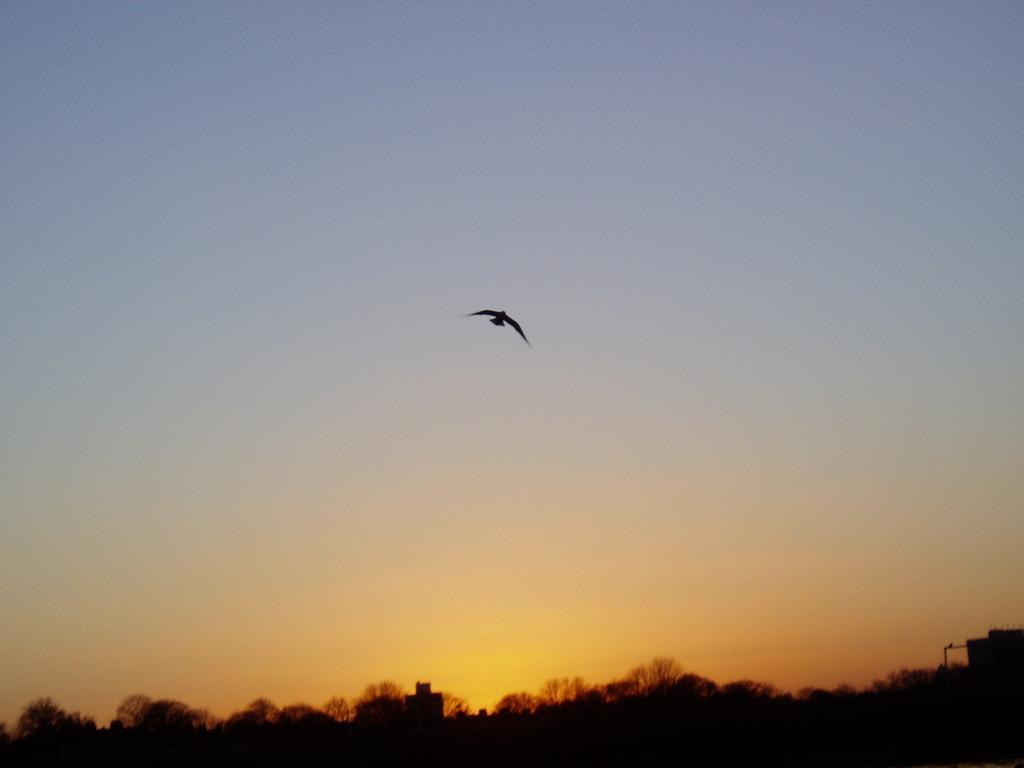What type of natural elements can be seen in the image? There are trees in the image. What type of man-made structures are present in the image? There are buildings in the image. Where are the trees and buildings located in the image? The trees and buildings are located at the bottom side of the image. What can be seen flying in the sky in the image? There is a bird in the sky in the image. How is the bird positioned in the image? The bird is in the center of the image. What time of day is it in the image, based on the presence of a dock? There is no dock present in the image, so it is not possible to determine the time of day based on that element. 